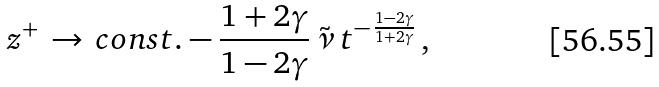<formula> <loc_0><loc_0><loc_500><loc_500>z ^ { + } \, \rightarrow \, c o n s t . - \frac { 1 + 2 \gamma } { 1 - 2 \gamma } \, \tilde { \nu } \, t ^ { - \, \frac { 1 - 2 \gamma } { 1 + 2 \gamma } } \, ,</formula> 